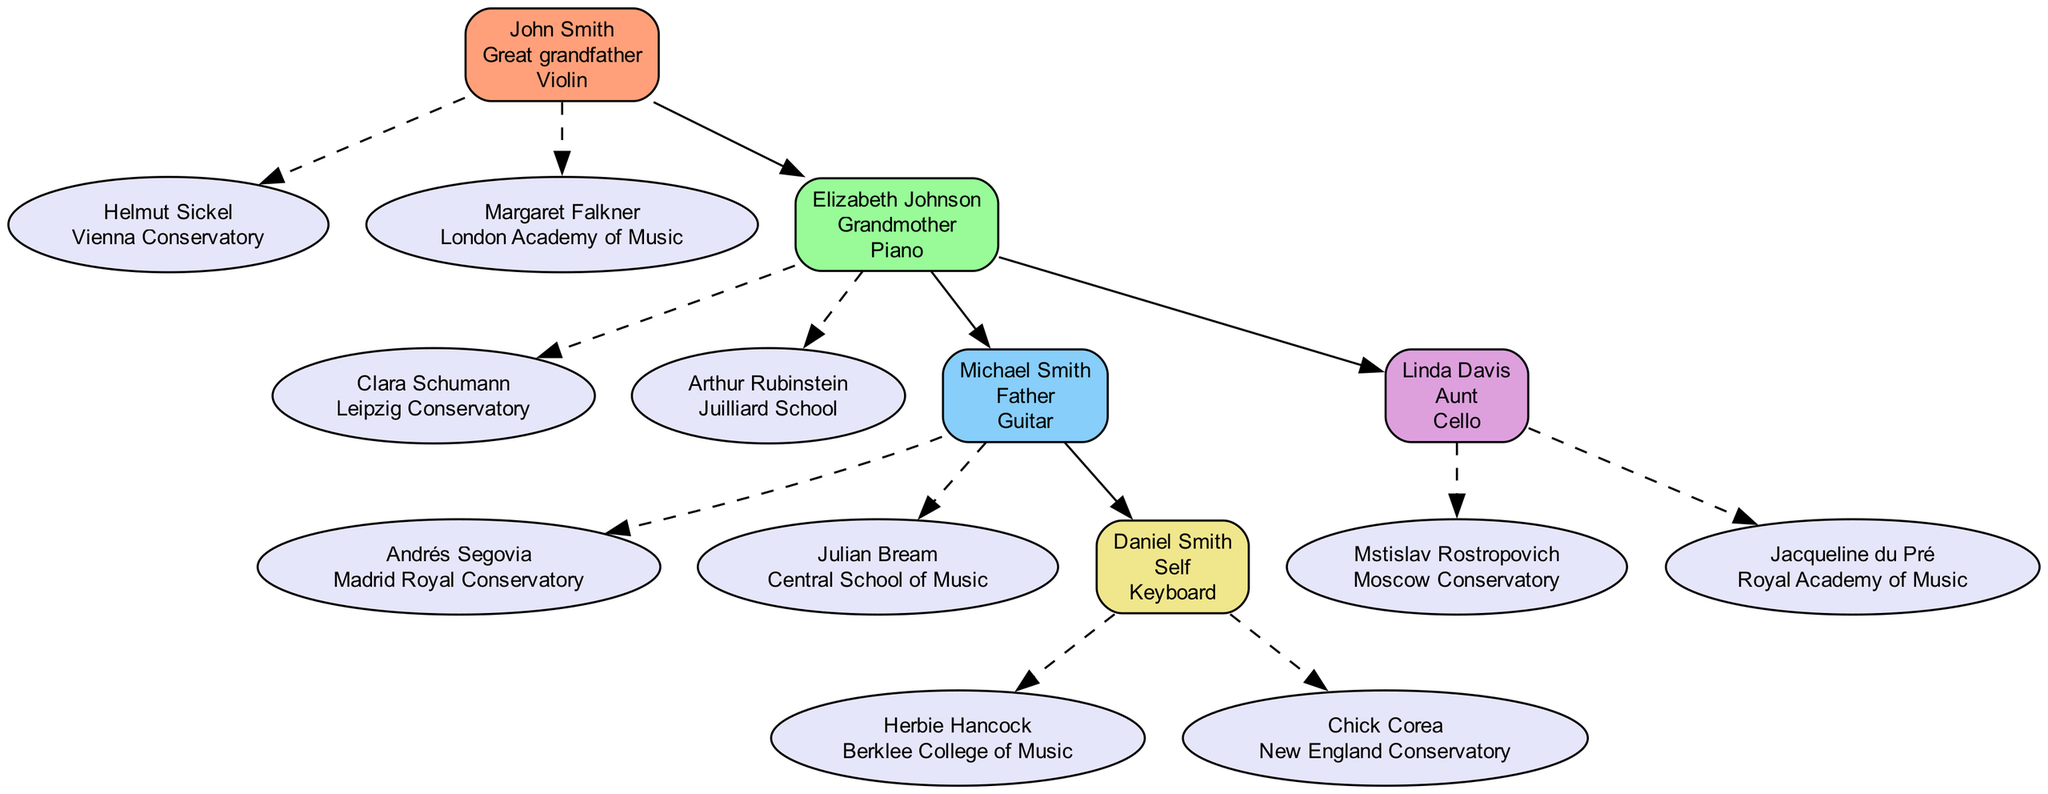What instrument did John Smith play? The diagram indicates that John Smith played the Violin, which is labeled on his node.
Answer: Violin Who is Daniel Smith's influential teacher from Berklee College of Music? In Daniel Smith's section of the diagram, one of his influential teachers is Herbie Hancock, who is associated with Berklee College of Music.
Answer: Herbie Hancock How many influential teachers did Michael Smith have? The diagram shows that Michael Smith has two influential teachers: Andrés Segovia and Julian Bream, each listed under his node.
Answer: 2 What is the relationship between Elizabeth Johnson and Michael Smith? In the family tree, the diagram shows that Elizabeth Johnson is the grandmother of Michael Smith, depicted by the edge connecting their nodes.
Answer: Grandmother Which institution did Clara Schumann teach at? The diagram provides information that Clara Schumann taught at the Leipzig Conservatory, which is listed beside her name in the diagram.
Answer: Leipzig Conservatory Which family member played the Cello? The diagram identifies Linda Davis as the family member who played the Cello, shown prominently on her node.
Answer: Linda Davis Who are the students of Elizabeth Johnson? The edge from Elizabeth Johnson leads to two nodes: Michael Smith and Linda Davis, indicating that they are her students, and she is their grandmother.
Answer: Michael Smith and Linda Davis How many family members are shown in the diagram? Counting the nodes on the diagram reveals five family members: John Smith, Elizabeth Johnson, Michael Smith, Linda Davis, and Daniel Smith.
Answer: 5 Which influential teacher is linked to the instrument Guitar? In the diagram, Michael Smith, who plays the Guitar, lists Andrés Segovia as one of his influential teachers, making the connection clear.
Answer: Andrés Segovia 